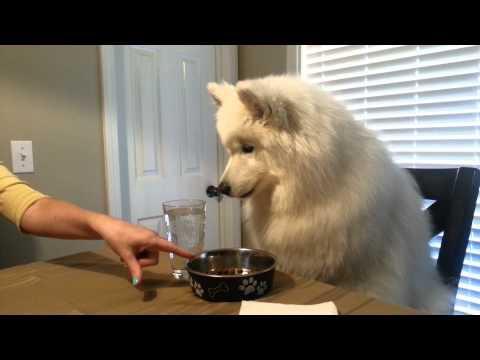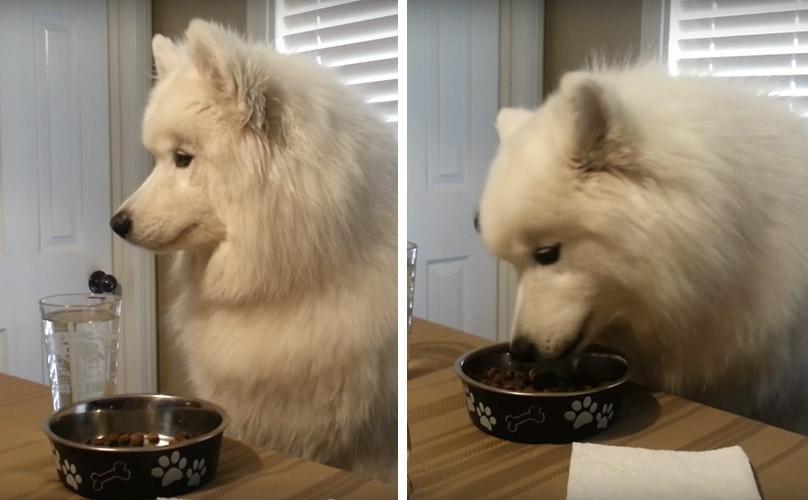The first image is the image on the left, the second image is the image on the right. Analyze the images presented: Is the assertion "An image shows a person's hand reaching from the right to offer something tasty to a white dog." valid? Answer yes or no. No. The first image is the image on the left, the second image is the image on the right. Examine the images to the left and right. Is the description "A person is placing something on a table in front of a dog in only one of the images." accurate? Answer yes or no. Yes. 